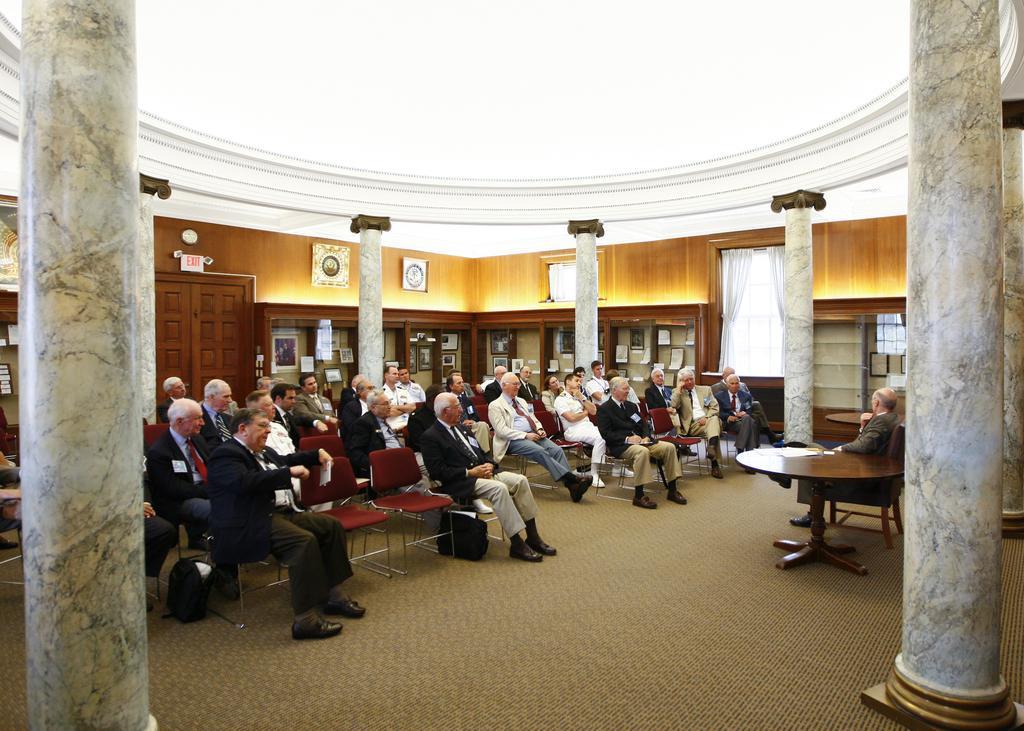Describe this image in one or two sentences. Group of people are sitting on chair. On this table there is a paper. Window with curtains. In this shelf there are different type of photos. This is door. These are pillars. Beside this person there is a bag on floor. 